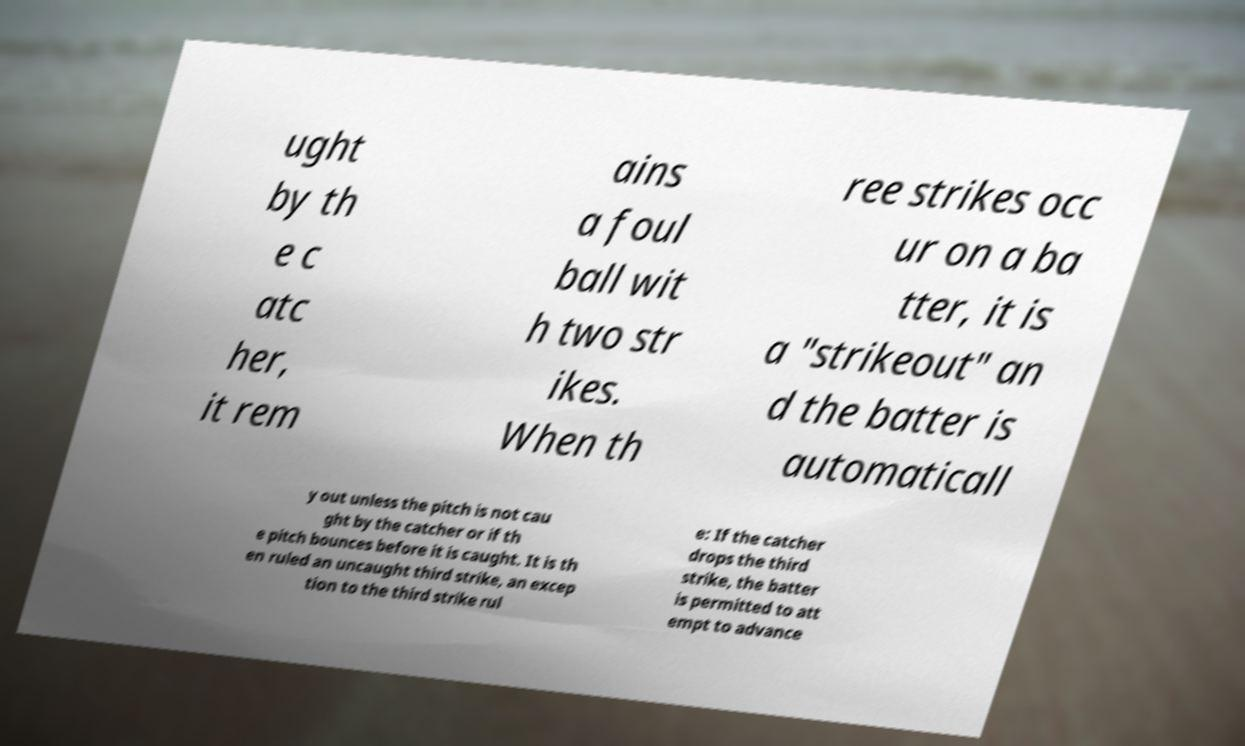Could you assist in decoding the text presented in this image and type it out clearly? ught by th e c atc her, it rem ains a foul ball wit h two str ikes. When th ree strikes occ ur on a ba tter, it is a "strikeout" an d the batter is automaticall y out unless the pitch is not cau ght by the catcher or if th e pitch bounces before it is caught. It is th en ruled an uncaught third strike, an excep tion to the third strike rul e: If the catcher drops the third strike, the batter is permitted to att empt to advance 